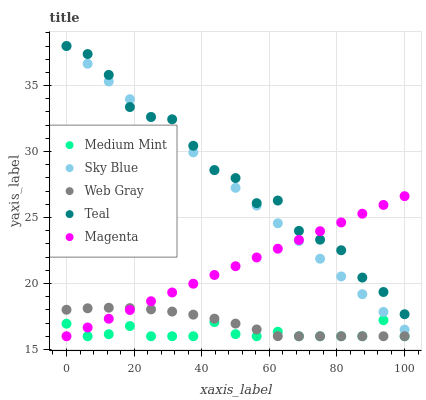Does Medium Mint have the minimum area under the curve?
Answer yes or no. Yes. Does Teal have the maximum area under the curve?
Answer yes or no. Yes. Does Sky Blue have the minimum area under the curve?
Answer yes or no. No. Does Sky Blue have the maximum area under the curve?
Answer yes or no. No. Is Magenta the smoothest?
Answer yes or no. Yes. Is Teal the roughest?
Answer yes or no. Yes. Is Sky Blue the smoothest?
Answer yes or no. No. Is Sky Blue the roughest?
Answer yes or no. No. Does Medium Mint have the lowest value?
Answer yes or no. Yes. Does Sky Blue have the lowest value?
Answer yes or no. No. Does Teal have the highest value?
Answer yes or no. Yes. Does Magenta have the highest value?
Answer yes or no. No. Is Medium Mint less than Sky Blue?
Answer yes or no. Yes. Is Sky Blue greater than Web Gray?
Answer yes or no. Yes. Does Magenta intersect Sky Blue?
Answer yes or no. Yes. Is Magenta less than Sky Blue?
Answer yes or no. No. Is Magenta greater than Sky Blue?
Answer yes or no. No. Does Medium Mint intersect Sky Blue?
Answer yes or no. No. 